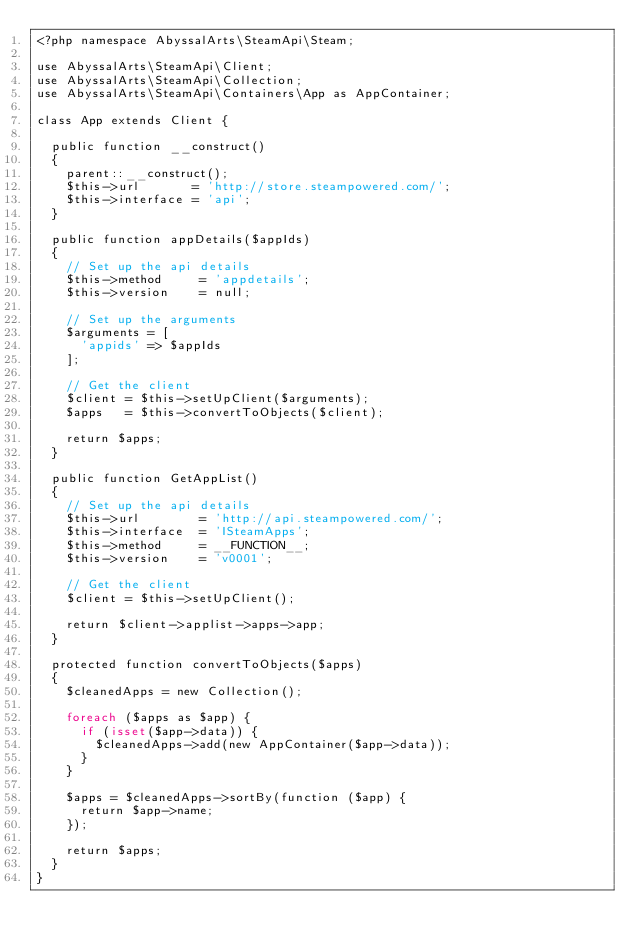<code> <loc_0><loc_0><loc_500><loc_500><_PHP_><?php namespace AbyssalArts\SteamApi\Steam;

use AbyssalArts\SteamApi\Client;
use AbyssalArts\SteamApi\Collection;
use AbyssalArts\SteamApi\Containers\App as AppContainer;

class App extends Client {

	public function __construct()
	{
		parent::__construct();
		$this->url       = 'http://store.steampowered.com/';
		$this->interface = 'api';
	}

	public function appDetails($appIds)
	{
		// Set up the api details
		$this->method     = 'appdetails';
		$this->version    = null;

		// Set up the arguments
		$arguments = [
			'appids' => $appIds
		];

		// Get the client
		$client = $this->setUpClient($arguments);
		$apps   = $this->convertToObjects($client);

		return $apps;
	}

	public function GetAppList()
	{
		// Set up the api details
		$this->url        = 'http://api.steampowered.com/';
		$this->interface  = 'ISteamApps';
		$this->method     = __FUNCTION__;
		$this->version    = 'v0001';

		// Get the client
		$client = $this->setUpClient();

		return $client->applist->apps->app;
	}

	protected function convertToObjects($apps)
	{
		$cleanedApps = new Collection();

		foreach ($apps as $app) {
			if (isset($app->data)) {
				$cleanedApps->add(new AppContainer($app->data));
			}
		}

		$apps = $cleanedApps->sortBy(function ($app) {
			return $app->name;
		});

		return $apps;
	}
}</code> 